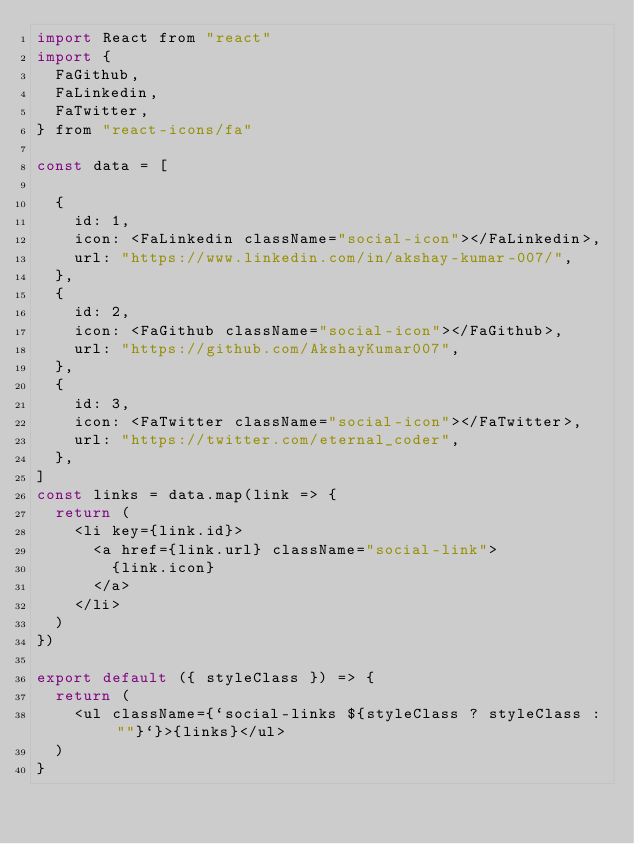Convert code to text. <code><loc_0><loc_0><loc_500><loc_500><_JavaScript_>import React from "react"
import {
  FaGithub,
  FaLinkedin,
  FaTwitter,
} from "react-icons/fa"

const data = [

  {
    id: 1,
    icon: <FaLinkedin className="social-icon"></FaLinkedin>,
    url: "https://www.linkedin.com/in/akshay-kumar-007/",
  },
  {
    id: 2,
    icon: <FaGithub className="social-icon"></FaGithub>,
    url: "https://github.com/AkshayKumar007",
  },
  {
    id: 3,
    icon: <FaTwitter className="social-icon"></FaTwitter>,
    url: "https://twitter.com/eternal_coder",
  },
]
const links = data.map(link => {
  return (
    <li key={link.id}>
      <a href={link.url} className="social-link">
        {link.icon}
      </a>
    </li>
  )
})

export default ({ styleClass }) => {
  return (
    <ul className={`social-links ${styleClass ? styleClass : ""}`}>{links}</ul>
  )
}
</code> 